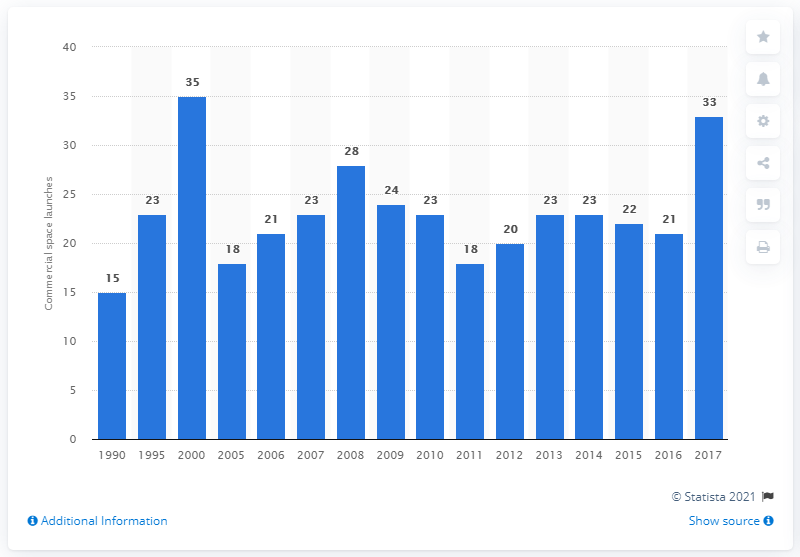Mention a couple of crucial points in this snapshot. In 2017, there were 33 commercial space launches. 